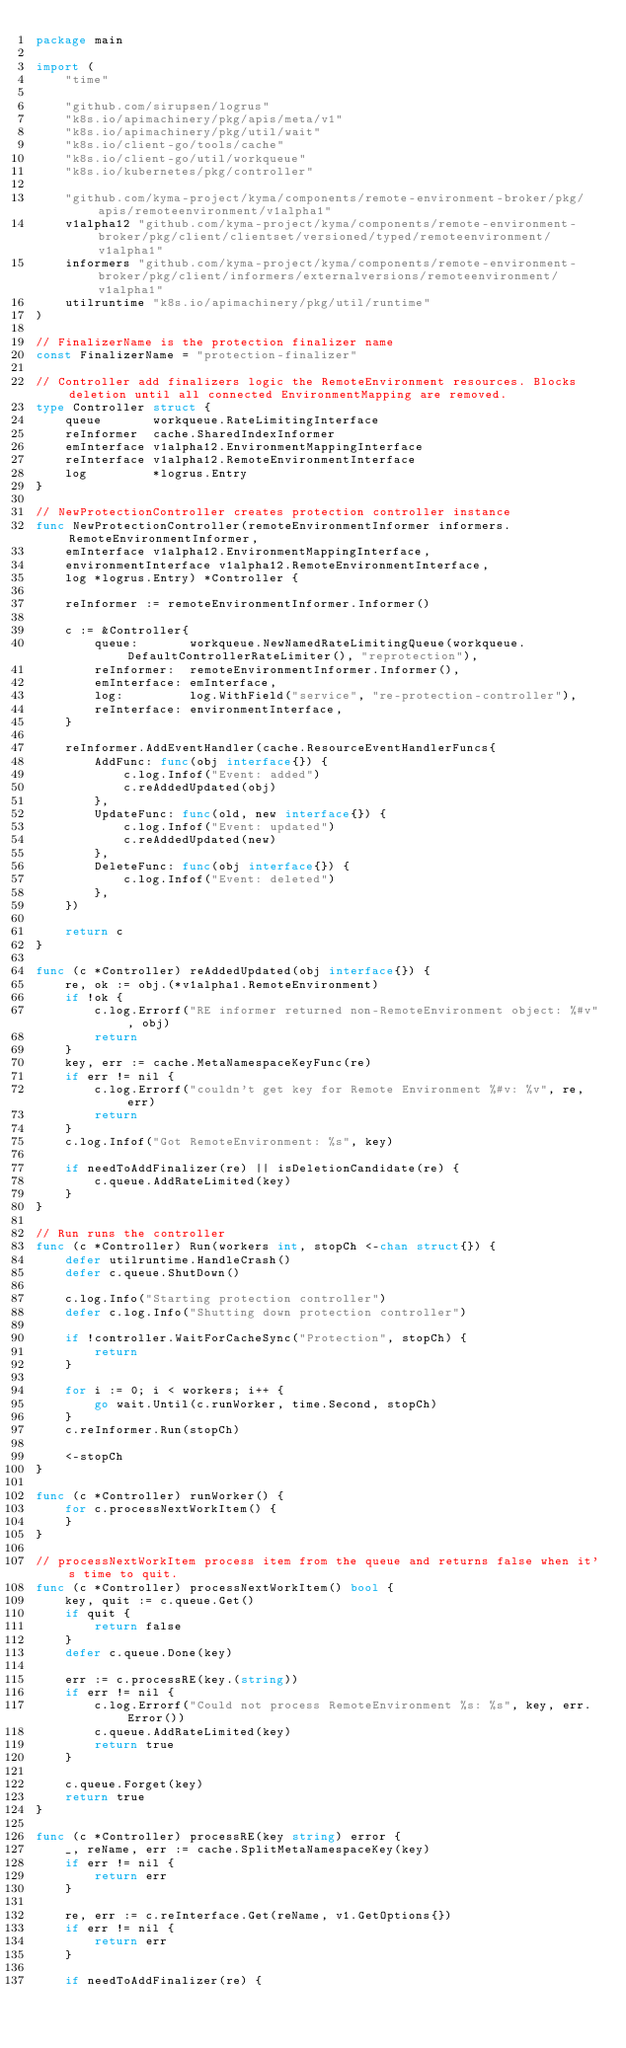Convert code to text. <code><loc_0><loc_0><loc_500><loc_500><_Go_>package main

import (
	"time"

	"github.com/sirupsen/logrus"
	"k8s.io/apimachinery/pkg/apis/meta/v1"
	"k8s.io/apimachinery/pkg/util/wait"
	"k8s.io/client-go/tools/cache"
	"k8s.io/client-go/util/workqueue"
	"k8s.io/kubernetes/pkg/controller"

	"github.com/kyma-project/kyma/components/remote-environment-broker/pkg/apis/remoteenvironment/v1alpha1"
	v1alpha12 "github.com/kyma-project/kyma/components/remote-environment-broker/pkg/client/clientset/versioned/typed/remoteenvironment/v1alpha1"
	informers "github.com/kyma-project/kyma/components/remote-environment-broker/pkg/client/informers/externalversions/remoteenvironment/v1alpha1"
	utilruntime "k8s.io/apimachinery/pkg/util/runtime"
)

// FinalizerName is the protection finalizer name
const FinalizerName = "protection-finalizer"

// Controller add finalizers logic the RemoteEnvironment resources. Blocks deletion until all connected EnvironmentMapping are removed.
type Controller struct {
	queue       workqueue.RateLimitingInterface
	reInformer  cache.SharedIndexInformer
	emInterface v1alpha12.EnvironmentMappingInterface
	reInterface v1alpha12.RemoteEnvironmentInterface
	log         *logrus.Entry
}

// NewProtectionController creates protection controller instance
func NewProtectionController(remoteEnvironmentInformer informers.RemoteEnvironmentInformer,
	emInterface v1alpha12.EnvironmentMappingInterface,
	environmentInterface v1alpha12.RemoteEnvironmentInterface,
	log *logrus.Entry) *Controller {

	reInformer := remoteEnvironmentInformer.Informer()

	c := &Controller{
		queue:       workqueue.NewNamedRateLimitingQueue(workqueue.DefaultControllerRateLimiter(), "reprotection"),
		reInformer:  remoteEnvironmentInformer.Informer(),
		emInterface: emInterface,
		log:         log.WithField("service", "re-protection-controller"),
		reInterface: environmentInterface,
	}

	reInformer.AddEventHandler(cache.ResourceEventHandlerFuncs{
		AddFunc: func(obj interface{}) {
			c.log.Infof("Event: added")
			c.reAddedUpdated(obj)
		},
		UpdateFunc: func(old, new interface{}) {
			c.log.Infof("Event: updated")
			c.reAddedUpdated(new)
		},
		DeleteFunc: func(obj interface{}) {
			c.log.Infof("Event: deleted")
		},
	})

	return c
}

func (c *Controller) reAddedUpdated(obj interface{}) {
	re, ok := obj.(*v1alpha1.RemoteEnvironment)
	if !ok {
		c.log.Errorf("RE informer returned non-RemoteEnvironment object: %#v", obj)
		return
	}
	key, err := cache.MetaNamespaceKeyFunc(re)
	if err != nil {
		c.log.Errorf("couldn't get key for Remote Environment %#v: %v", re, err)
		return
	}
	c.log.Infof("Got RemoteEnvironment: %s", key)

	if needToAddFinalizer(re) || isDeletionCandidate(re) {
		c.queue.AddRateLimited(key)
	}
}

// Run runs the controller
func (c *Controller) Run(workers int, stopCh <-chan struct{}) {
	defer utilruntime.HandleCrash()
	defer c.queue.ShutDown()

	c.log.Info("Starting protection controller")
	defer c.log.Info("Shutting down protection controller")

	if !controller.WaitForCacheSync("Protection", stopCh) {
		return
	}

	for i := 0; i < workers; i++ {
		go wait.Until(c.runWorker, time.Second, stopCh)
	}
	c.reInformer.Run(stopCh)

	<-stopCh
}

func (c *Controller) runWorker() {
	for c.processNextWorkItem() {
	}
}

// processNextWorkItem process item from the queue and returns false when it's time to quit.
func (c *Controller) processNextWorkItem() bool {
	key, quit := c.queue.Get()
	if quit {
		return false
	}
	defer c.queue.Done(key)

	err := c.processRE(key.(string))
	if err != nil {
		c.log.Errorf("Could not process RemoteEnvironment %s: %s", key, err.Error())
		c.queue.AddRateLimited(key)
		return true
	}

	c.queue.Forget(key)
	return true
}

func (c *Controller) processRE(key string) error {
	_, reName, err := cache.SplitMetaNamespaceKey(key)
	if err != nil {
		return err
	}

	re, err := c.reInterface.Get(reName, v1.GetOptions{})
	if err != nil {
		return err
	}

	if needToAddFinalizer(re) {</code> 